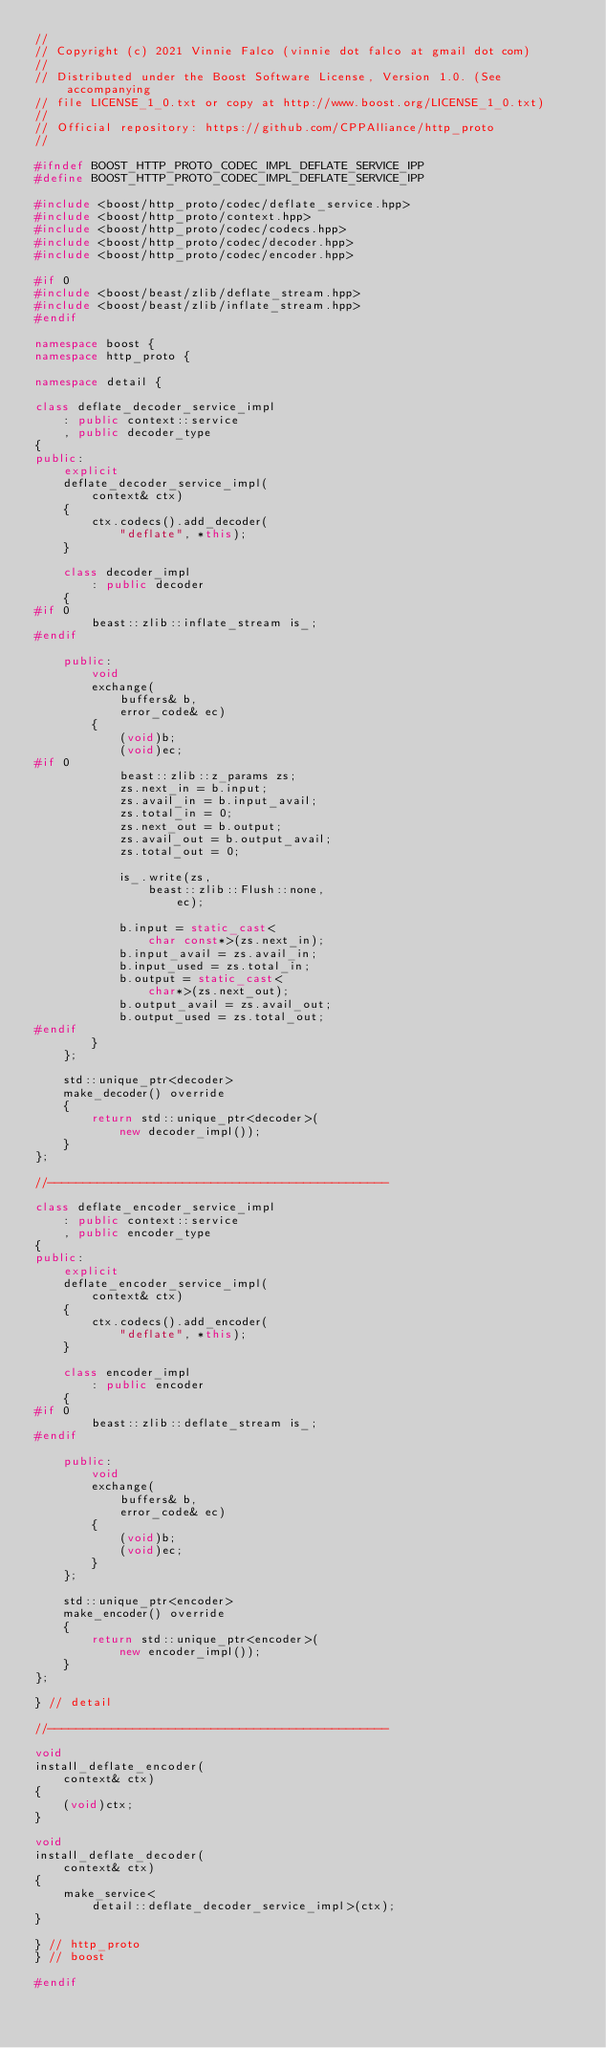Convert code to text. <code><loc_0><loc_0><loc_500><loc_500><_C++_>//
// Copyright (c) 2021 Vinnie Falco (vinnie dot falco at gmail dot com)
//
// Distributed under the Boost Software License, Version 1.0. (See accompanying
// file LICENSE_1_0.txt or copy at http://www.boost.org/LICENSE_1_0.txt)
//
// Official repository: https://github.com/CPPAlliance/http_proto
//

#ifndef BOOST_HTTP_PROTO_CODEC_IMPL_DEFLATE_SERVICE_IPP
#define BOOST_HTTP_PROTO_CODEC_IMPL_DEFLATE_SERVICE_IPP

#include <boost/http_proto/codec/deflate_service.hpp>
#include <boost/http_proto/context.hpp>
#include <boost/http_proto/codec/codecs.hpp>
#include <boost/http_proto/codec/decoder.hpp>
#include <boost/http_proto/codec/encoder.hpp>

#if 0
#include <boost/beast/zlib/deflate_stream.hpp>
#include <boost/beast/zlib/inflate_stream.hpp>
#endif

namespace boost {
namespace http_proto {

namespace detail {

class deflate_decoder_service_impl
    : public context::service
    , public decoder_type
{
public:
    explicit
    deflate_decoder_service_impl(
        context& ctx)
    {
        ctx.codecs().add_decoder(
            "deflate", *this);
    }

    class decoder_impl
        : public decoder
    {
#if 0
        beast::zlib::inflate_stream is_;
#endif

    public:
        void
        exchange(
            buffers& b,
            error_code& ec)
        {
            (void)b;
            (void)ec;
#if 0
            beast::zlib::z_params zs;
            zs.next_in = b.input;
            zs.avail_in = b.input_avail;
            zs.total_in = 0;
            zs.next_out = b.output;
            zs.avail_out = b.output_avail;
            zs.total_out = 0;

            is_.write(zs,
                beast::zlib::Flush::none,
                    ec);

            b.input = static_cast<
                char const*>(zs.next_in);
            b.input_avail = zs.avail_in;
            b.input_used = zs.total_in;
            b.output = static_cast<
                char*>(zs.next_out);
            b.output_avail = zs.avail_out;
            b.output_used = zs.total_out;
#endif
        }
    };

    std::unique_ptr<decoder>
    make_decoder() override
    {
        return std::unique_ptr<decoder>(
            new decoder_impl());
    }
};

//------------------------------------------------

class deflate_encoder_service_impl
    : public context::service
    , public encoder_type
{
public:
    explicit
    deflate_encoder_service_impl(
        context& ctx)
    {
        ctx.codecs().add_encoder(
            "deflate", *this);
    }

    class encoder_impl
        : public encoder
    {
#if 0
        beast::zlib::deflate_stream is_;
#endif

    public:
        void
        exchange(
            buffers& b,
            error_code& ec)
        {
            (void)b;
            (void)ec;
        }
    };

    std::unique_ptr<encoder>
    make_encoder() override
    {
        return std::unique_ptr<encoder>(
            new encoder_impl());
    }
};

} // detail

//------------------------------------------------

void
install_deflate_encoder(
    context& ctx)
{
    (void)ctx;
}

void
install_deflate_decoder(
    context& ctx)
{
    make_service<
        detail::deflate_decoder_service_impl>(ctx);
}

} // http_proto
} // boost

#endif
</code> 